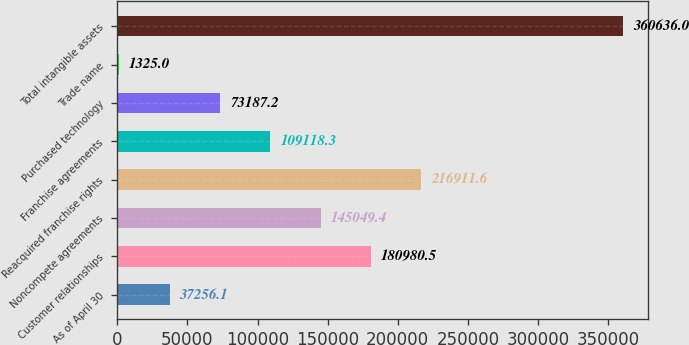<chart> <loc_0><loc_0><loc_500><loc_500><bar_chart><fcel>As of April 30<fcel>Customer relationships<fcel>Noncompete agreements<fcel>Reacquired franchise rights<fcel>Franchise agreements<fcel>Purchased technology<fcel>Trade name<fcel>Total intangible assets<nl><fcel>37256.1<fcel>180980<fcel>145049<fcel>216912<fcel>109118<fcel>73187.2<fcel>1325<fcel>360636<nl></chart> 